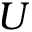<formula> <loc_0><loc_0><loc_500><loc_500>U</formula> 